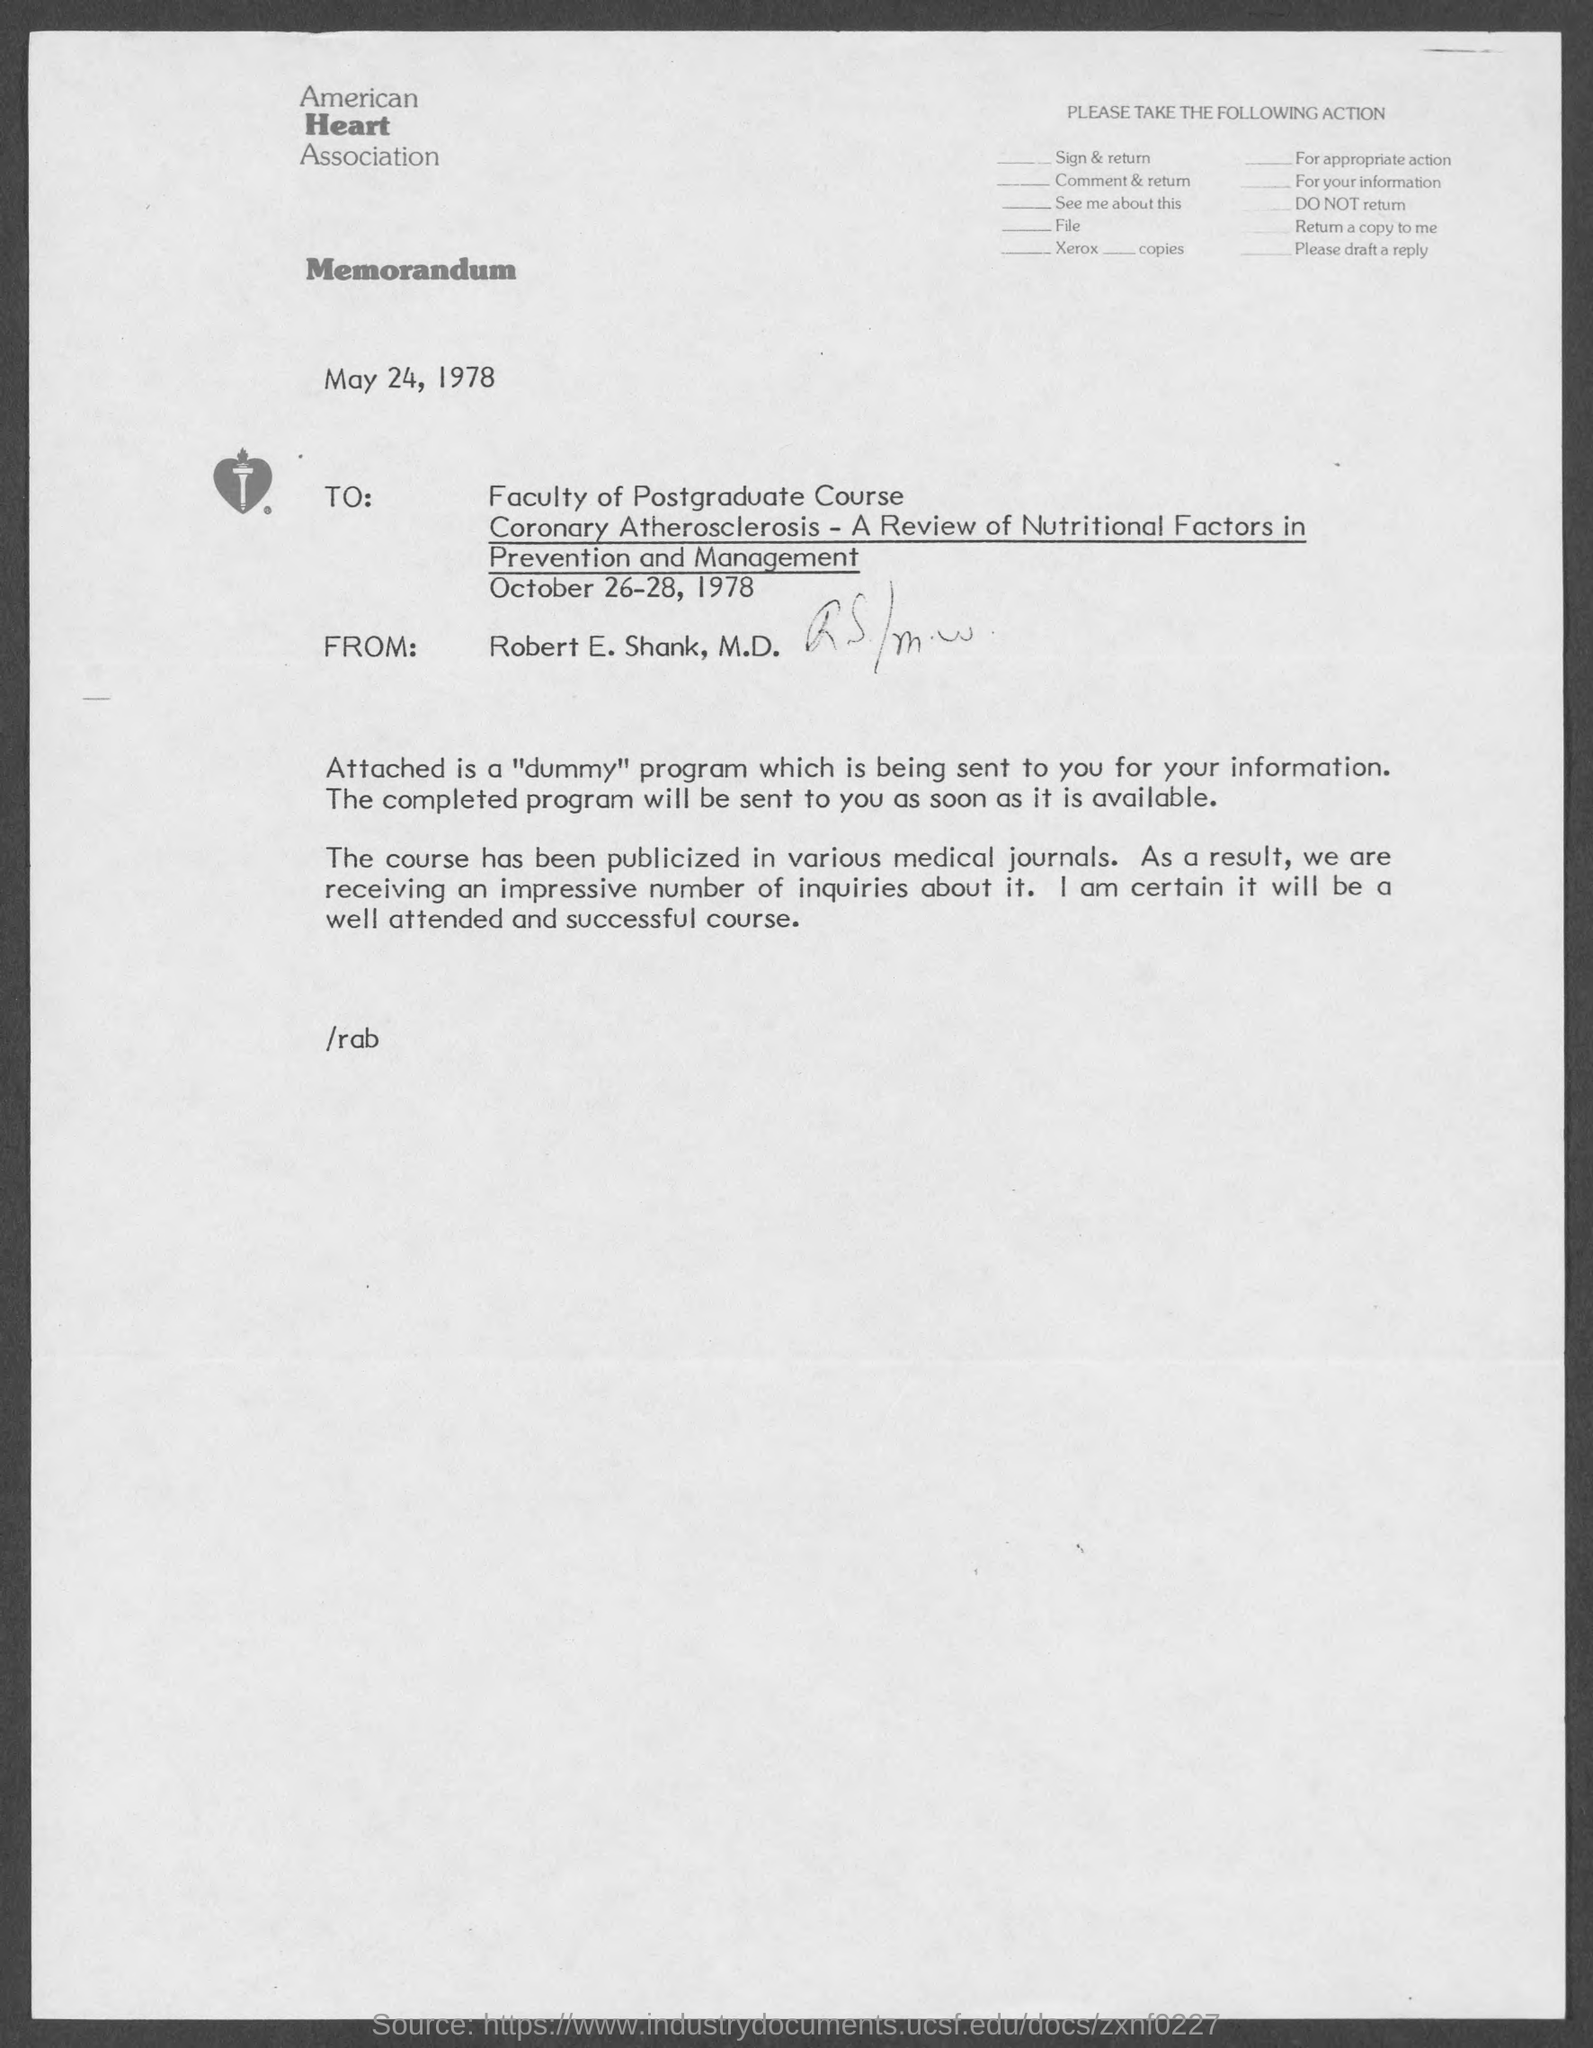When is the memorandum dated?
Keep it short and to the point. May 24, 1978. What is the from address in memorandum ?
Keep it short and to the point. Robert E. Shank, M.D. What is the name of heart association ?
Keep it short and to the point. American heart association. 